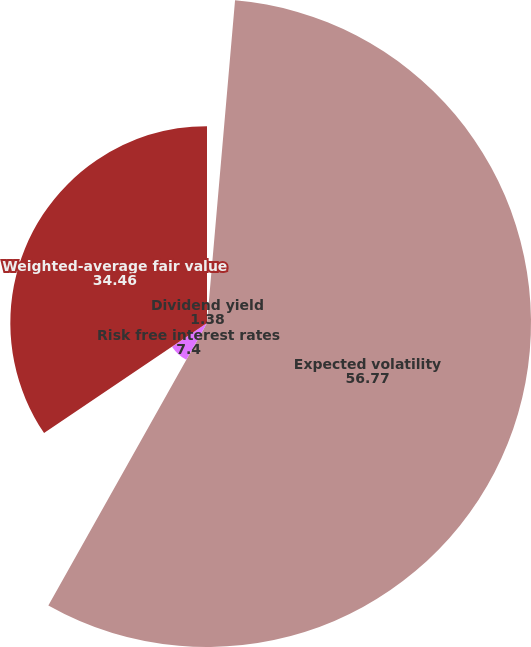Convert chart. <chart><loc_0><loc_0><loc_500><loc_500><pie_chart><fcel>Dividend yield<fcel>Expected volatility<fcel>Risk free interest rates<fcel>Weighted-average fair value<nl><fcel>1.38%<fcel>56.77%<fcel>7.4%<fcel>34.46%<nl></chart> 